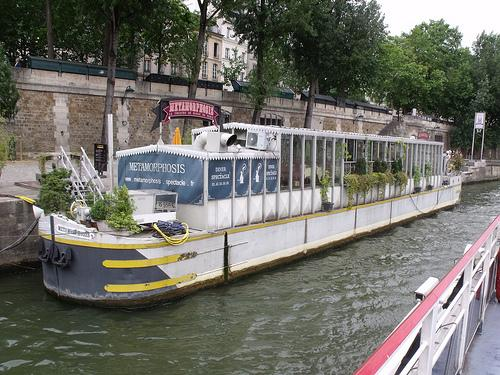What kind of plants are growing on the blue and white boat? The blue and white boat has green plants growing on it, including some small trees on the front. Provide a brief description of the primary elements and their colors in the image. The image features a blue and white boat with green plants on it, a second boat with red railing, a yellow patio umbrella, green trees, and dark water in a river. What is the main mode of transportation depicted in the photo? The main mode of transportation is a long blue and white boat on a heavily used river. What are the different colors of the boats in the image? The first boat is blue and white, while the second boat has white, red and black elements. Narrate the scene involving green plants and windows in the image. Green plants are growing on the blue and white boat and are placed alongside its glass windows, giving it a unique aesthetic. What activities or events are taking place by or on the river? There are two boats on the river, one with green vegetation on it and the other enclosed with windows, with a red safety fence around it. Mention the various structures and safety measures present in the image. There are green trees, a red safety fence, white metal stairs, white metal exhaust tube, and a tall sign in the distance. Give a brief description of both boats and their unique features. One is a long blue and white boat with green plants and glass windows, the other boat has a red railing, and it appears to be enclosed with windows. Describe the state of the water seen in the image. The river is filled with dark water containing ripples on its surface due to the activity of boats. Describe any text or signage present in the image. There is a banner telling the name of the blue and white boat, a black and red sign, a tall sign in the distance, and multiple blue signs on the side of the boat. 